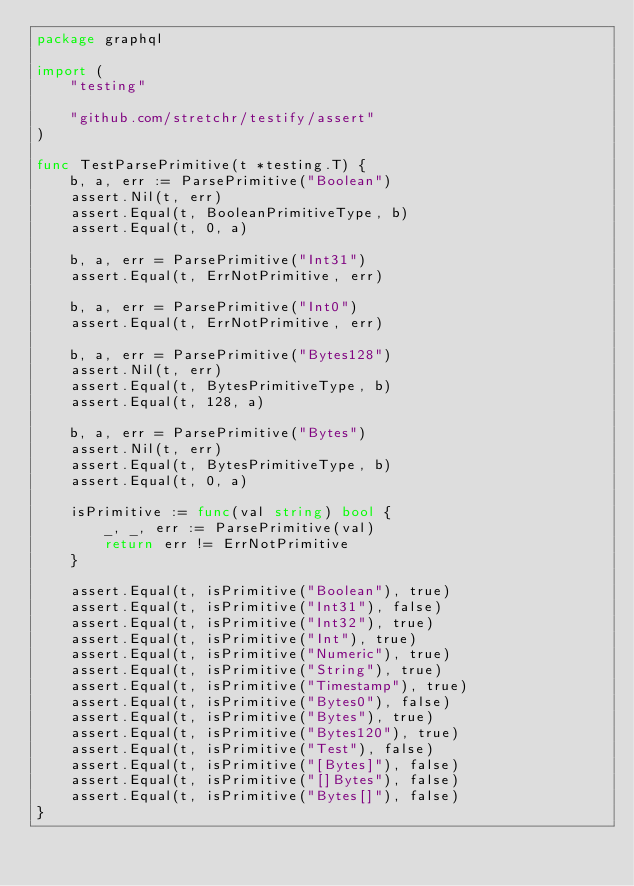Convert code to text. <code><loc_0><loc_0><loc_500><loc_500><_Go_>package graphql

import (
	"testing"

	"github.com/stretchr/testify/assert"
)

func TestParsePrimitive(t *testing.T) {
	b, a, err := ParsePrimitive("Boolean")
	assert.Nil(t, err)
	assert.Equal(t, BooleanPrimitiveType, b)
	assert.Equal(t, 0, a)

	b, a, err = ParsePrimitive("Int31")
	assert.Equal(t, ErrNotPrimitive, err)

	b, a, err = ParsePrimitive("Int0")
	assert.Equal(t, ErrNotPrimitive, err)

	b, a, err = ParsePrimitive("Bytes128")
	assert.Nil(t, err)
	assert.Equal(t, BytesPrimitiveType, b)
	assert.Equal(t, 128, a)

	b, a, err = ParsePrimitive("Bytes")
	assert.Nil(t, err)
	assert.Equal(t, BytesPrimitiveType, b)
	assert.Equal(t, 0, a)

	isPrimitive := func(val string) bool {
		_, _, err := ParsePrimitive(val)
		return err != ErrNotPrimitive
	}

	assert.Equal(t, isPrimitive("Boolean"), true)
	assert.Equal(t, isPrimitive("Int31"), false)
	assert.Equal(t, isPrimitive("Int32"), true)
	assert.Equal(t, isPrimitive("Int"), true)
	assert.Equal(t, isPrimitive("Numeric"), true)
	assert.Equal(t, isPrimitive("String"), true)
	assert.Equal(t, isPrimitive("Timestamp"), true)
	assert.Equal(t, isPrimitive("Bytes0"), false)
	assert.Equal(t, isPrimitive("Bytes"), true)
	assert.Equal(t, isPrimitive("Bytes120"), true)
	assert.Equal(t, isPrimitive("Test"), false)
	assert.Equal(t, isPrimitive("[Bytes]"), false)
	assert.Equal(t, isPrimitive("[]Bytes"), false)
	assert.Equal(t, isPrimitive("Bytes[]"), false)
}
</code> 